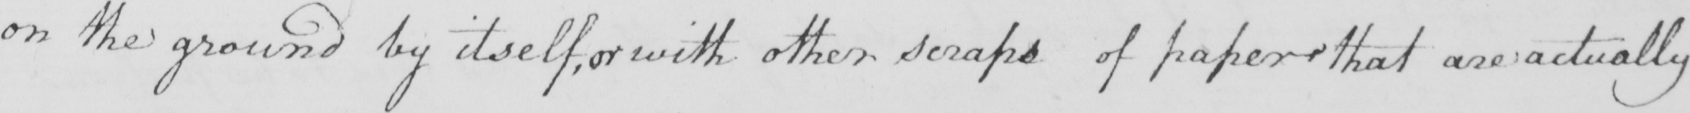Can you read and transcribe this handwriting? on the ground by itself , or with other scraps of paper that are actually 